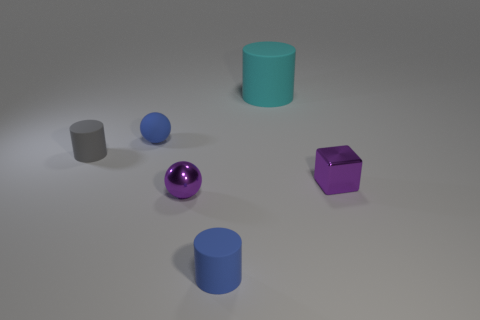Add 2 tiny green matte objects. How many objects exist? 8 Subtract all balls. How many objects are left? 4 Add 3 small gray rubber cylinders. How many small gray rubber cylinders exist? 4 Subtract 0 cyan spheres. How many objects are left? 6 Subtract all metal cubes. Subtract all tiny things. How many objects are left? 0 Add 2 small things. How many small things are left? 7 